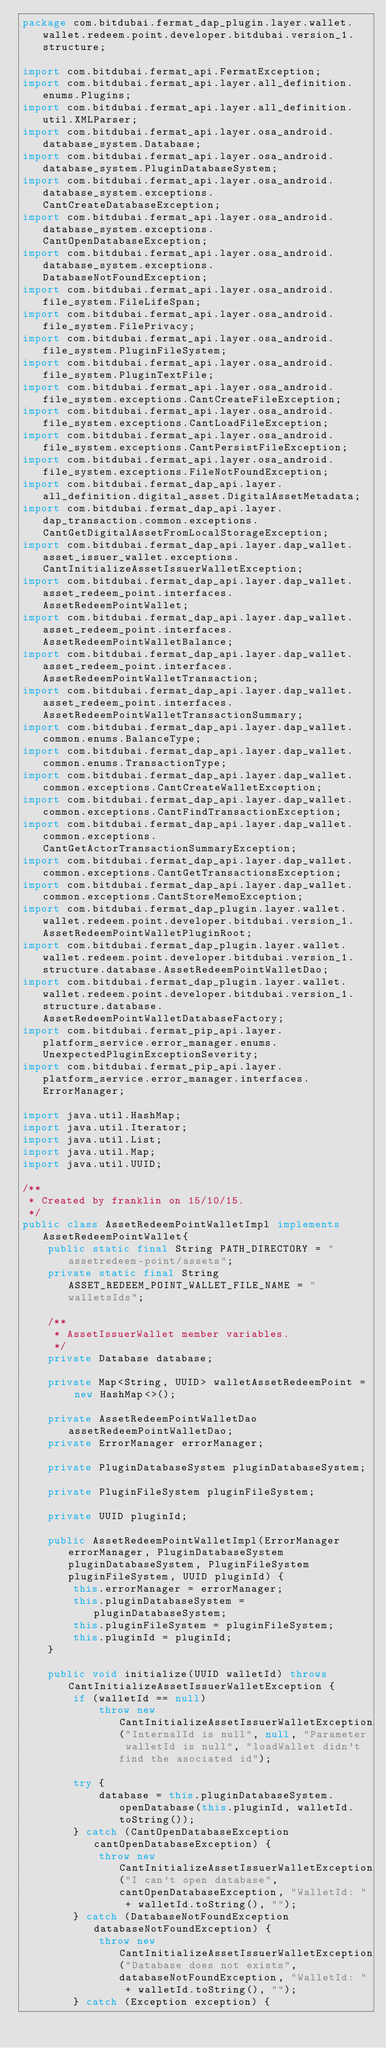Convert code to text. <code><loc_0><loc_0><loc_500><loc_500><_Java_>package com.bitdubai.fermat_dap_plugin.layer.wallet.wallet.redeem.point.developer.bitdubai.version_1.structure;

import com.bitdubai.fermat_api.FermatException;
import com.bitdubai.fermat_api.layer.all_definition.enums.Plugins;
import com.bitdubai.fermat_api.layer.all_definition.util.XMLParser;
import com.bitdubai.fermat_api.layer.osa_android.database_system.Database;
import com.bitdubai.fermat_api.layer.osa_android.database_system.PluginDatabaseSystem;
import com.bitdubai.fermat_api.layer.osa_android.database_system.exceptions.CantCreateDatabaseException;
import com.bitdubai.fermat_api.layer.osa_android.database_system.exceptions.CantOpenDatabaseException;
import com.bitdubai.fermat_api.layer.osa_android.database_system.exceptions.DatabaseNotFoundException;
import com.bitdubai.fermat_api.layer.osa_android.file_system.FileLifeSpan;
import com.bitdubai.fermat_api.layer.osa_android.file_system.FilePrivacy;
import com.bitdubai.fermat_api.layer.osa_android.file_system.PluginFileSystem;
import com.bitdubai.fermat_api.layer.osa_android.file_system.PluginTextFile;
import com.bitdubai.fermat_api.layer.osa_android.file_system.exceptions.CantCreateFileException;
import com.bitdubai.fermat_api.layer.osa_android.file_system.exceptions.CantLoadFileException;
import com.bitdubai.fermat_api.layer.osa_android.file_system.exceptions.CantPersistFileException;
import com.bitdubai.fermat_api.layer.osa_android.file_system.exceptions.FileNotFoundException;
import com.bitdubai.fermat_dap_api.layer.all_definition.digital_asset.DigitalAssetMetadata;
import com.bitdubai.fermat_dap_api.layer.dap_transaction.common.exceptions.CantGetDigitalAssetFromLocalStorageException;
import com.bitdubai.fermat_dap_api.layer.dap_wallet.asset_issuer_wallet.exceptions.CantInitializeAssetIssuerWalletException;
import com.bitdubai.fermat_dap_api.layer.dap_wallet.asset_redeem_point.interfaces.AssetRedeemPointWallet;
import com.bitdubai.fermat_dap_api.layer.dap_wallet.asset_redeem_point.interfaces.AssetRedeemPointWalletBalance;
import com.bitdubai.fermat_dap_api.layer.dap_wallet.asset_redeem_point.interfaces.AssetRedeemPointWalletTransaction;
import com.bitdubai.fermat_dap_api.layer.dap_wallet.asset_redeem_point.interfaces.AssetRedeemPointWalletTransactionSummary;
import com.bitdubai.fermat_dap_api.layer.dap_wallet.common.enums.BalanceType;
import com.bitdubai.fermat_dap_api.layer.dap_wallet.common.enums.TransactionType;
import com.bitdubai.fermat_dap_api.layer.dap_wallet.common.exceptions.CantCreateWalletException;
import com.bitdubai.fermat_dap_api.layer.dap_wallet.common.exceptions.CantFindTransactionException;
import com.bitdubai.fermat_dap_api.layer.dap_wallet.common.exceptions.CantGetActorTransactionSummaryException;
import com.bitdubai.fermat_dap_api.layer.dap_wallet.common.exceptions.CantGetTransactionsException;
import com.bitdubai.fermat_dap_api.layer.dap_wallet.common.exceptions.CantStoreMemoException;
import com.bitdubai.fermat_dap_plugin.layer.wallet.wallet.redeem.point.developer.bitdubai.version_1.AssetRedeemPointWalletPluginRoot;
import com.bitdubai.fermat_dap_plugin.layer.wallet.wallet.redeem.point.developer.bitdubai.version_1.structure.database.AssetRedeemPointWalletDao;
import com.bitdubai.fermat_dap_plugin.layer.wallet.wallet.redeem.point.developer.bitdubai.version_1.structure.database.AssetRedeemPointWalletDatabaseFactory;
import com.bitdubai.fermat_pip_api.layer.platform_service.error_manager.enums.UnexpectedPluginExceptionSeverity;
import com.bitdubai.fermat_pip_api.layer.platform_service.error_manager.interfaces.ErrorManager;

import java.util.HashMap;
import java.util.Iterator;
import java.util.List;
import java.util.Map;
import java.util.UUID;

/**
 * Created by franklin on 15/10/15.
 */
public class AssetRedeemPointWalletImpl implements AssetRedeemPointWallet{
    public static final String PATH_DIRECTORY = "assetredeem-point/assets";
    private static final String ASSET_REDEEM_POINT_WALLET_FILE_NAME = "walletsIds";

    /**
     * AssetIssuerWallet member variables.
     */
    private Database database;

    private Map<String, UUID> walletAssetRedeemPoint = new HashMap<>();

    private AssetRedeemPointWalletDao assetRedeemPointWalletDao;
    private ErrorManager errorManager;

    private PluginDatabaseSystem pluginDatabaseSystem;

    private PluginFileSystem pluginFileSystem;

    private UUID pluginId;

    public AssetRedeemPointWalletImpl(ErrorManager errorManager, PluginDatabaseSystem pluginDatabaseSystem, PluginFileSystem pluginFileSystem, UUID pluginId) {
        this.errorManager = errorManager;
        this.pluginDatabaseSystem = pluginDatabaseSystem;
        this.pluginFileSystem = pluginFileSystem;
        this.pluginId = pluginId;
    }

    public void initialize(UUID walletId) throws CantInitializeAssetIssuerWalletException {
        if (walletId == null)
            throw new CantInitializeAssetIssuerWalletException("InternalId is null", null, "Parameter walletId is null", "loadWallet didn't find the asociated id");

        try {
            database = this.pluginDatabaseSystem.openDatabase(this.pluginId, walletId.toString());
        } catch (CantOpenDatabaseException cantOpenDatabaseException) {
            throw new CantInitializeAssetIssuerWalletException("I can't open database", cantOpenDatabaseException, "WalletId: " + walletId.toString(), "");
        } catch (DatabaseNotFoundException databaseNotFoundException) {
            throw new CantInitializeAssetIssuerWalletException("Database does not exists", databaseNotFoundException, "WalletId: " + walletId.toString(), "");
        } catch (Exception exception) {</code> 